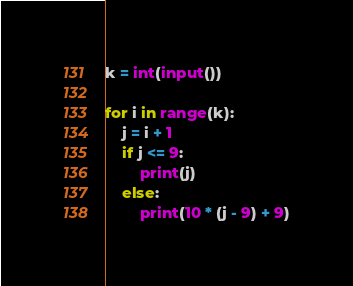<code> <loc_0><loc_0><loc_500><loc_500><_Python_>k = int(input())

for i in range(k):
    j = i + 1
    if j <= 9:
        print(j)
    else:
        print(10 * (j - 9) + 9)</code> 